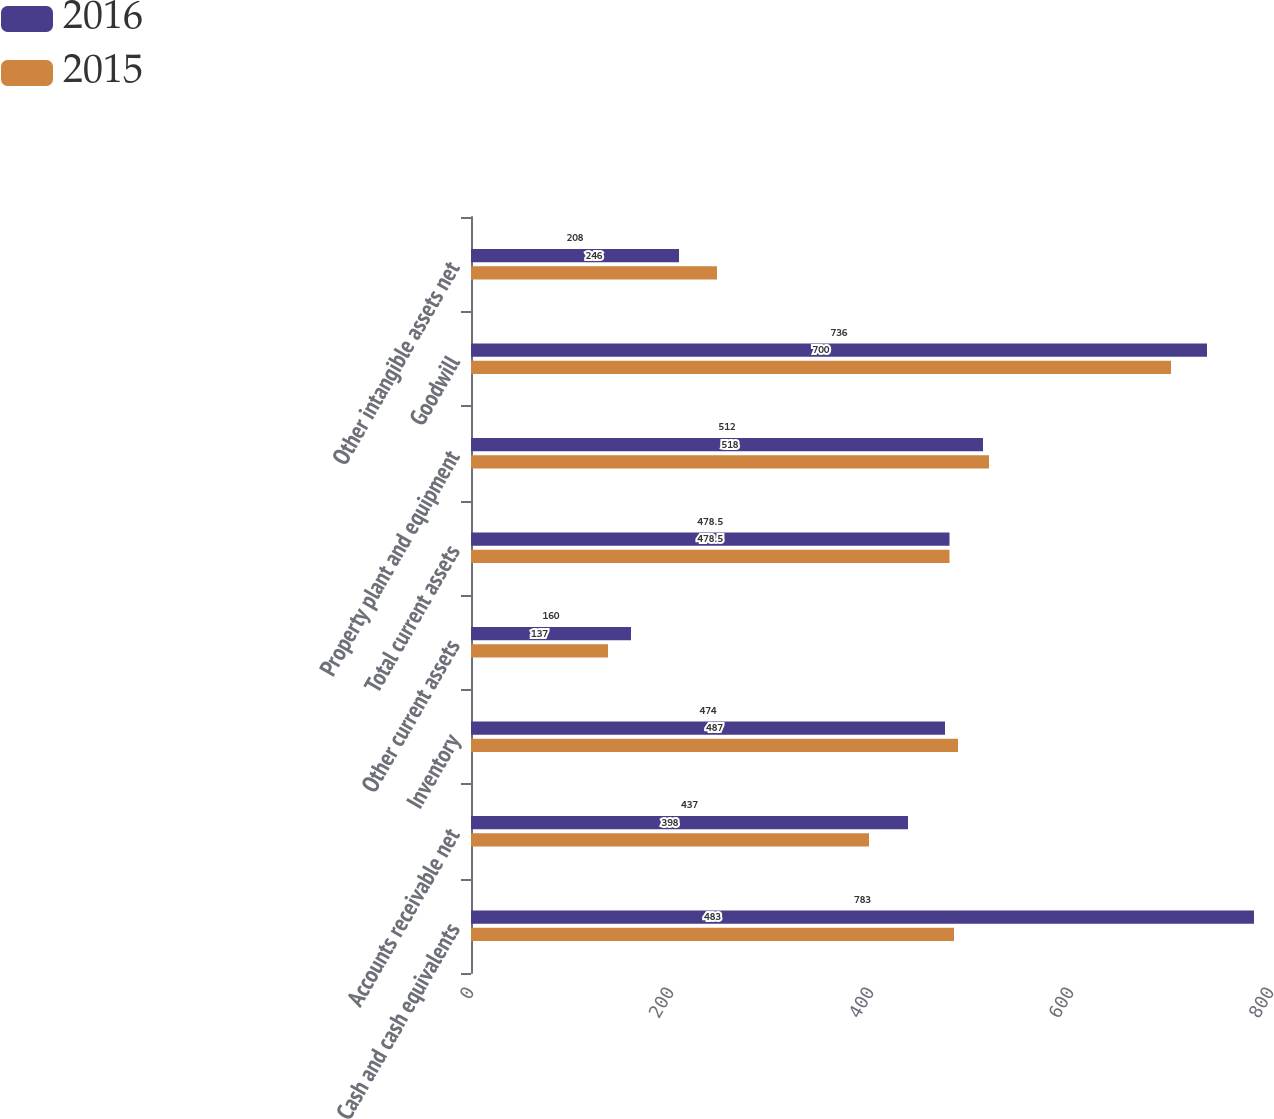<chart> <loc_0><loc_0><loc_500><loc_500><stacked_bar_chart><ecel><fcel>Cash and cash equivalents<fcel>Accounts receivable net<fcel>Inventory<fcel>Other current assets<fcel>Total current assets<fcel>Property plant and equipment<fcel>Goodwill<fcel>Other intangible assets net<nl><fcel>2016<fcel>783<fcel>437<fcel>474<fcel>160<fcel>478.5<fcel>512<fcel>736<fcel>208<nl><fcel>2015<fcel>483<fcel>398<fcel>487<fcel>137<fcel>478.5<fcel>518<fcel>700<fcel>246<nl></chart> 